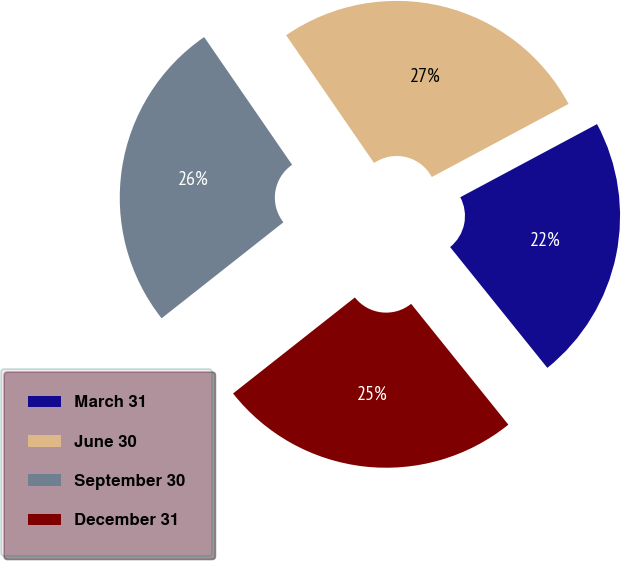<chart> <loc_0><loc_0><loc_500><loc_500><pie_chart><fcel>March 31<fcel>June 30<fcel>September 30<fcel>December 31<nl><fcel>22.03%<fcel>26.78%<fcel>26.03%<fcel>25.16%<nl></chart> 